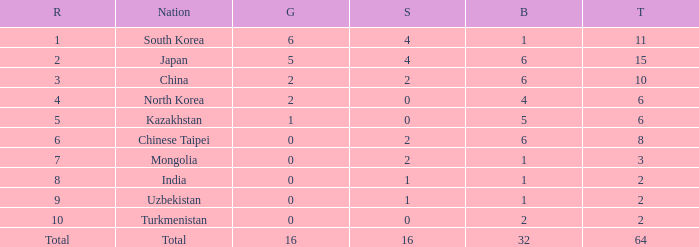What rank is Turkmenistan, who had 0 silver's and Less than 2 golds? 10.0. 